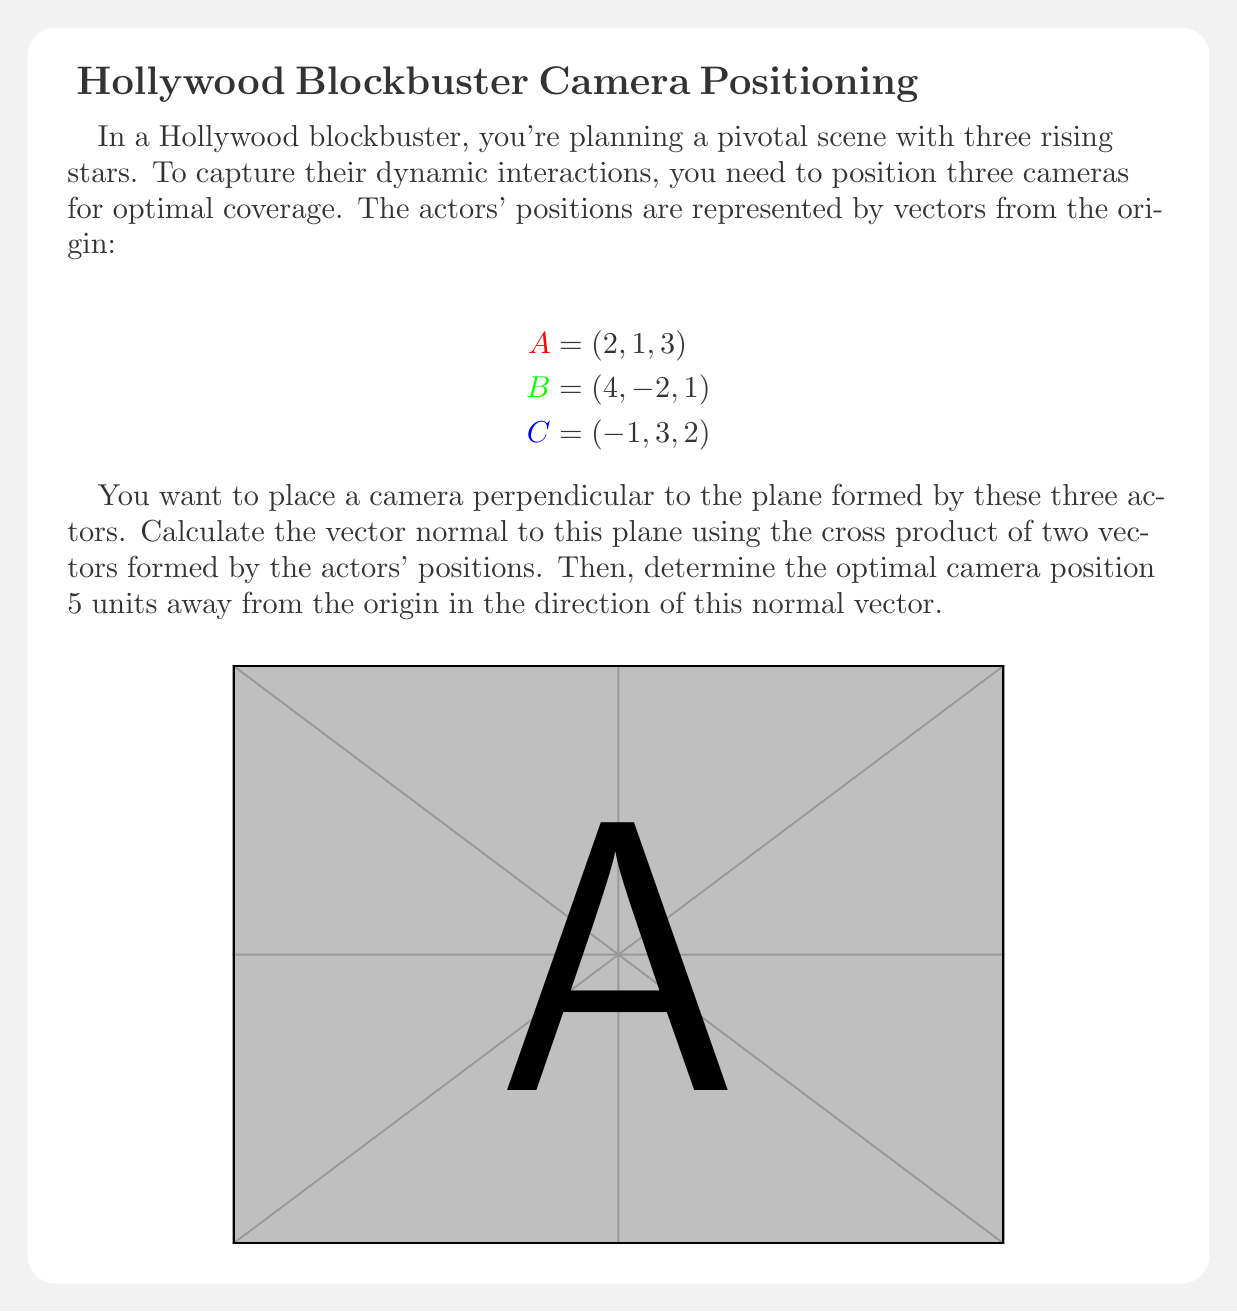Give your solution to this math problem. Let's approach this step-by-step:

1) First, we need to find two vectors on the plane. We can do this by subtracting the position vectors:

   $$\vec{AB} = B - A = (4, -2, 1) - (2, 1, 3) = (2, -3, -2)$$
   $$\vec{AC} = C - A = (-1, 3, 2) - (2, 1, 3) = (-3, 2, -1)$$

2) The normal vector to the plane is the cross product of these two vectors:

   $$\vec{n} = \vec{AB} \times \vec{AC}$$

3) Calculate the cross product:

   $$\vec{n} = \begin{vmatrix} 
   i & j & k \\
   2 & -3 & -2 \\
   -3 & 2 & -1
   \end{vmatrix}$$

   $$= ((-3)(-1) - (-2)(2))i - ((2)(-1) - (-2)(-3))j + ((2)(2) - (-3)(-3))k$$
   
   $$= (-3 + 4)i - (-2 + 6)j + (4 - 9)k$$
   
   $$= i - 8j - 5k$$

4) So, the normal vector is $\vec{n} = (1, -8, -5)$

5) To find the unit vector in this direction, we normalize $\vec{n}$:

   $$\|\vec{n}\| = \sqrt{1^2 + (-8)^2 + (-5)^2} = \sqrt{90}$$

   $$\hat{n} = \frac{\vec{n}}{\|\vec{n}\|} = (\frac{1}{\sqrt{90}}, \frac{-8}{\sqrt{90}}, \frac{-5}{\sqrt{90}})$$

6) The camera position is 5 units in this direction:

   $$\text{Camera} = 5\hat{n} = (\frac{5}{\sqrt{90}}, \frac{-40}{\sqrt{90}}, \frac{-25}{\sqrt{90}})$$
Answer: $(\frac{5}{\sqrt{90}}, \frac{-40}{\sqrt{90}}, \frac{-25}{\sqrt{90}})$ 